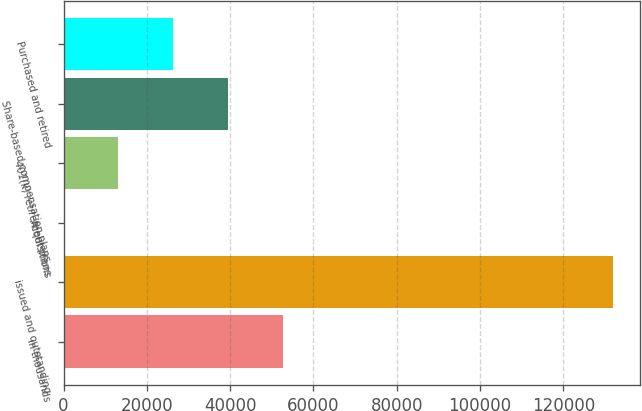Convert chart. <chart><loc_0><loc_0><loc_500><loc_500><bar_chart><fcel>in thousands<fcel>issued and outstanding<fcel>Acquisitions<fcel>401(k) retirement plans<fcel>Share-based compensation plans<fcel>Purchased and retired<nl><fcel>52763.4<fcel>131907<fcel>0.95<fcel>13191.6<fcel>39572.8<fcel>26382.2<nl></chart> 